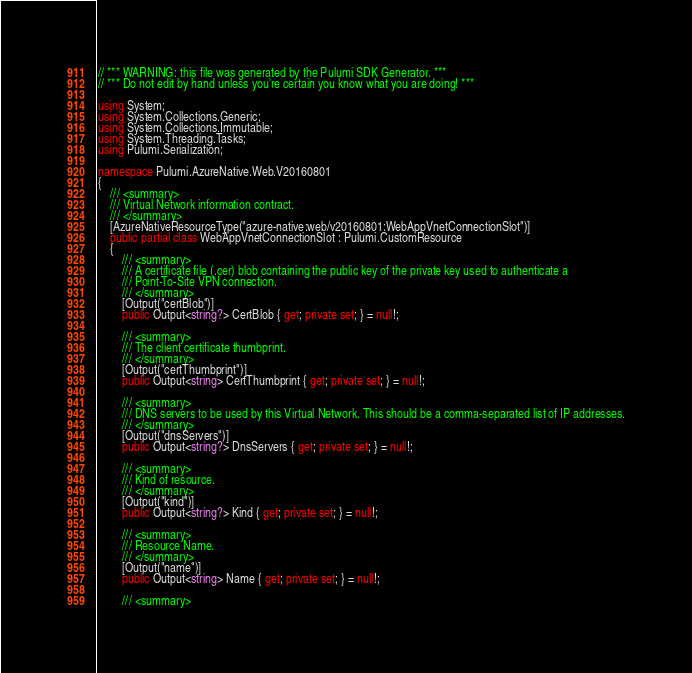Convert code to text. <code><loc_0><loc_0><loc_500><loc_500><_C#_>// *** WARNING: this file was generated by the Pulumi SDK Generator. ***
// *** Do not edit by hand unless you're certain you know what you are doing! ***

using System;
using System.Collections.Generic;
using System.Collections.Immutable;
using System.Threading.Tasks;
using Pulumi.Serialization;

namespace Pulumi.AzureNative.Web.V20160801
{
    /// <summary>
    /// Virtual Network information contract.
    /// </summary>
    [AzureNativeResourceType("azure-native:web/v20160801:WebAppVnetConnectionSlot")]
    public partial class WebAppVnetConnectionSlot : Pulumi.CustomResource
    {
        /// <summary>
        /// A certificate file (.cer) blob containing the public key of the private key used to authenticate a 
        /// Point-To-Site VPN connection.
        /// </summary>
        [Output("certBlob")]
        public Output<string?> CertBlob { get; private set; } = null!;

        /// <summary>
        /// The client certificate thumbprint.
        /// </summary>
        [Output("certThumbprint")]
        public Output<string> CertThumbprint { get; private set; } = null!;

        /// <summary>
        /// DNS servers to be used by this Virtual Network. This should be a comma-separated list of IP addresses.
        /// </summary>
        [Output("dnsServers")]
        public Output<string?> DnsServers { get; private set; } = null!;

        /// <summary>
        /// Kind of resource.
        /// </summary>
        [Output("kind")]
        public Output<string?> Kind { get; private set; } = null!;

        /// <summary>
        /// Resource Name.
        /// </summary>
        [Output("name")]
        public Output<string> Name { get; private set; } = null!;

        /// <summary></code> 